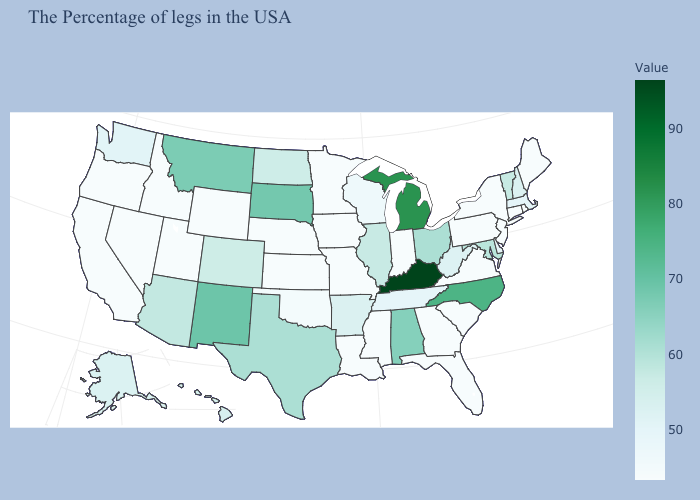Which states have the lowest value in the USA?
Write a very short answer. Maine, Rhode Island, Connecticut, New York, New Jersey, Pennsylvania, Virginia, South Carolina, Florida, Georgia, Indiana, Mississippi, Louisiana, Missouri, Minnesota, Iowa, Kansas, Nebraska, Wyoming, Utah, Idaho, Nevada, California, Oregon. Does New Hampshire have a higher value than Texas?
Short answer required. No. Among the states that border California , which have the lowest value?
Be succinct. Nevada, Oregon. Is the legend a continuous bar?
Write a very short answer. Yes. Which states have the lowest value in the USA?
Concise answer only. Maine, Rhode Island, Connecticut, New York, New Jersey, Pennsylvania, Virginia, South Carolina, Florida, Georgia, Indiana, Mississippi, Louisiana, Missouri, Minnesota, Iowa, Kansas, Nebraska, Wyoming, Utah, Idaho, Nevada, California, Oregon. Is the legend a continuous bar?
Be succinct. Yes. Is the legend a continuous bar?
Write a very short answer. Yes. Which states have the lowest value in the South?
Short answer required. Virginia, South Carolina, Florida, Georgia, Mississippi, Louisiana. 